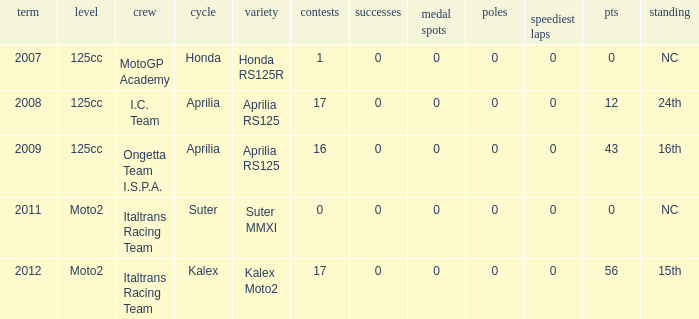What's Italtrans Racing Team's, with 0 pts, class? Moto2. 